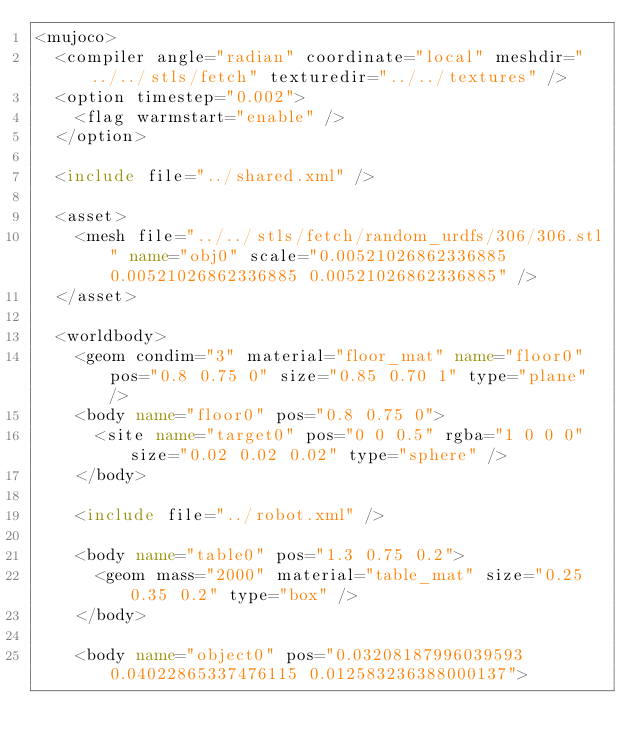<code> <loc_0><loc_0><loc_500><loc_500><_XML_><mujoco>
	<compiler angle="radian" coordinate="local" meshdir="../../stls/fetch" texturedir="../../textures" />
	<option timestep="0.002">
		<flag warmstart="enable" />
	</option>

	<include file="../shared.xml" />

	<asset>
		<mesh file="../../stls/fetch/random_urdfs/306/306.stl" name="obj0" scale="0.00521026862336885 0.00521026862336885 0.00521026862336885" />
	</asset>

	<worldbody>
		<geom condim="3" material="floor_mat" name="floor0" pos="0.8 0.75 0" size="0.85 0.70 1" type="plane" />
		<body name="floor0" pos="0.8 0.75 0">
			<site name="target0" pos="0 0 0.5" rgba="1 0 0 0" size="0.02 0.02 0.02" type="sphere" />
		</body>

		<include file="../robot.xml" />

		<body name="table0" pos="1.3 0.75 0.2">
			<geom mass="2000" material="table_mat" size="0.25 0.35 0.2" type="box" />
		</body>

		<body name="object0" pos="0.03208187996039593 0.04022865337476115 0.012583236388000137"></code> 